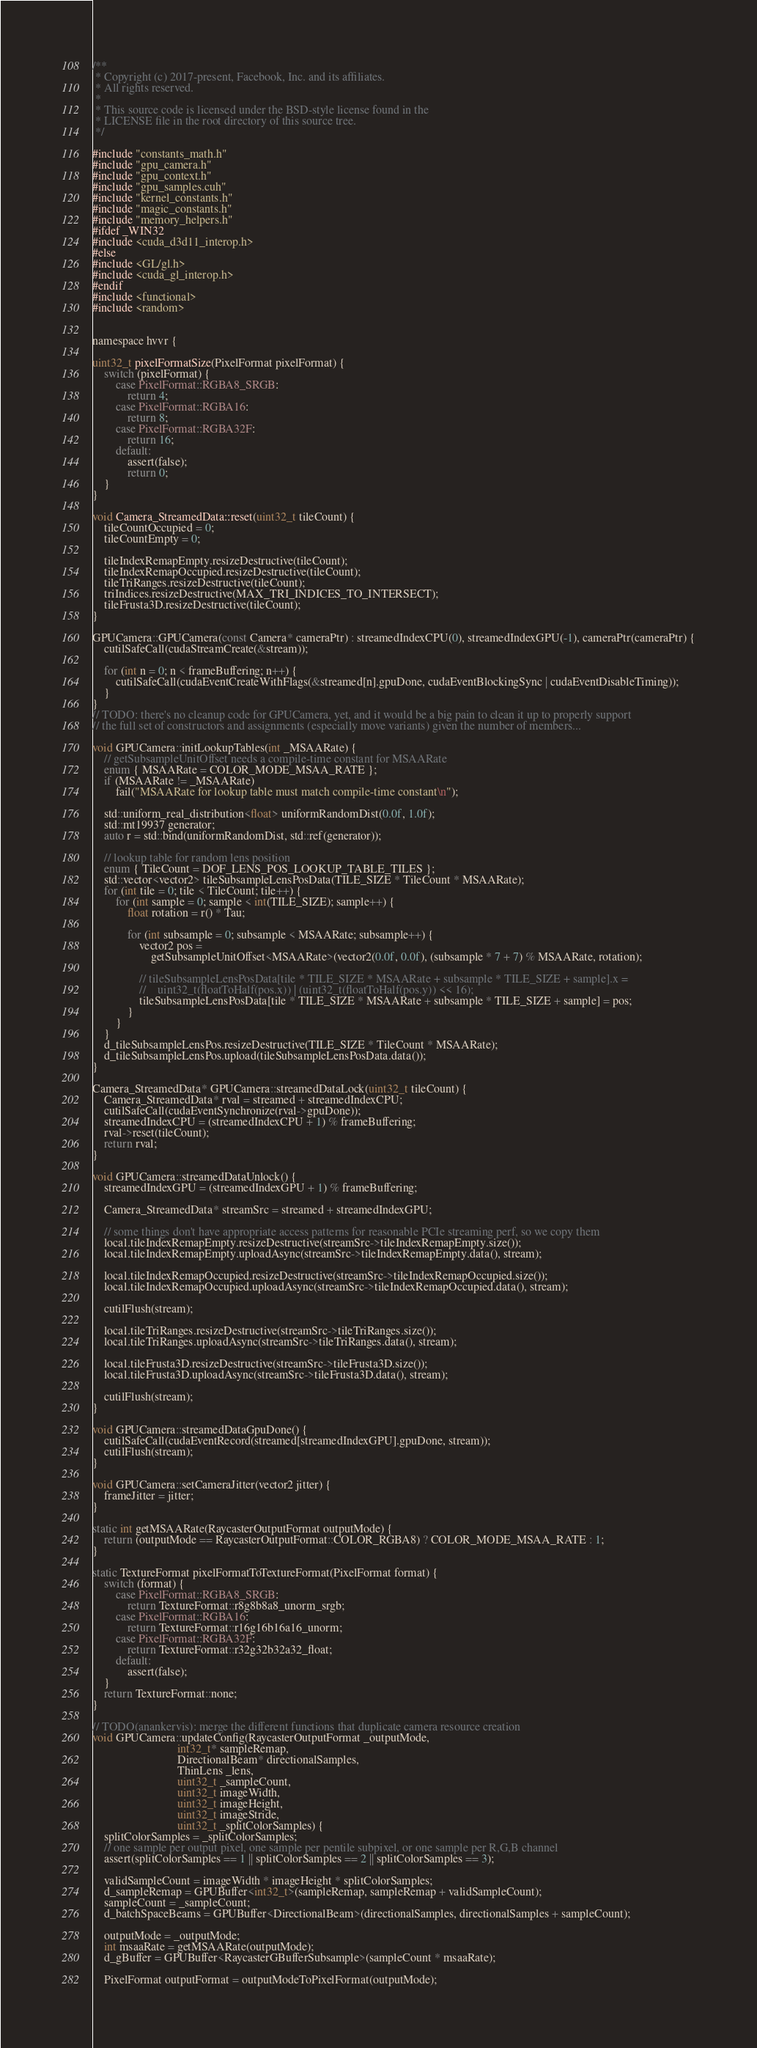<code> <loc_0><loc_0><loc_500><loc_500><_Cuda_>/**
 * Copyright (c) 2017-present, Facebook, Inc. and its affiliates.
 * All rights reserved.
 *
 * This source code is licensed under the BSD-style license found in the
 * LICENSE file in the root directory of this source tree.
 */

#include "constants_math.h"
#include "gpu_camera.h"
#include "gpu_context.h"
#include "gpu_samples.cuh"
#include "kernel_constants.h"
#include "magic_constants.h"
#include "memory_helpers.h"
#ifdef _WIN32
#include <cuda_d3d11_interop.h>
#else
#include <GL/gl.h>
#include <cuda_gl_interop.h>
#endif
#include <functional>
#include <random>


namespace hvvr {

uint32_t pixelFormatSize(PixelFormat pixelFormat) {
    switch (pixelFormat) {
        case PixelFormat::RGBA8_SRGB:
            return 4;
        case PixelFormat::RGBA16:
            return 8;
        case PixelFormat::RGBA32F:
            return 16;
        default:
            assert(false);
            return 0;
    }
}

void Camera_StreamedData::reset(uint32_t tileCount) {
    tileCountOccupied = 0;
    tileCountEmpty = 0;

    tileIndexRemapEmpty.resizeDestructive(tileCount);
    tileIndexRemapOccupied.resizeDestructive(tileCount);
    tileTriRanges.resizeDestructive(tileCount);
    triIndices.resizeDestructive(MAX_TRI_INDICES_TO_INTERSECT);
    tileFrusta3D.resizeDestructive(tileCount);
}

GPUCamera::GPUCamera(const Camera* cameraPtr) : streamedIndexCPU(0), streamedIndexGPU(-1), cameraPtr(cameraPtr) {
    cutilSafeCall(cudaStreamCreate(&stream));

    for (int n = 0; n < frameBuffering; n++) {
        cutilSafeCall(cudaEventCreateWithFlags(&streamed[n].gpuDone, cudaEventBlockingSync | cudaEventDisableTiming));
    }
}
// TODO: there's no cleanup code for GPUCamera, yet, and it would be a big pain to clean it up to properly support
// the full set of constructors and assignments (especially move variants) given the number of members...

void GPUCamera::initLookupTables(int _MSAARate) {
    // getSubsampleUnitOffset needs a compile-time constant for MSAARate
    enum { MSAARate = COLOR_MODE_MSAA_RATE };
    if (MSAARate != _MSAARate)
        fail("MSAARate for lookup table must match compile-time constant\n");

    std::uniform_real_distribution<float> uniformRandomDist(0.0f, 1.0f);
    std::mt19937 generator;
    auto r = std::bind(uniformRandomDist, std::ref(generator));

    // lookup table for random lens position
    enum { TileCount = DOF_LENS_POS_LOOKUP_TABLE_TILES };
    std::vector<vector2> tileSubsampleLensPosData(TILE_SIZE * TileCount * MSAARate);
    for (int tile = 0; tile < TileCount; tile++) {
        for (int sample = 0; sample < int(TILE_SIZE); sample++) {
            float rotation = r() * Tau;

            for (int subsample = 0; subsample < MSAARate; subsample++) {
                vector2 pos =
                    getSubsampleUnitOffset<MSAARate>(vector2(0.0f, 0.0f), (subsample * 7 + 7) % MSAARate, rotation);

                // tileSubsampleLensPosData[tile * TILE_SIZE * MSAARate + subsample * TILE_SIZE + sample].x =
                //    uint32_t(floatToHalf(pos.x)) | (uint32_t(floatToHalf(pos.y)) << 16);
                tileSubsampleLensPosData[tile * TILE_SIZE * MSAARate + subsample * TILE_SIZE + sample] = pos;
            }
        }
    }
    d_tileSubsampleLensPos.resizeDestructive(TILE_SIZE * TileCount * MSAARate);
    d_tileSubsampleLensPos.upload(tileSubsampleLensPosData.data());
}

Camera_StreamedData* GPUCamera::streamedDataLock(uint32_t tileCount) {
    Camera_StreamedData* rval = streamed + streamedIndexCPU;
    cutilSafeCall(cudaEventSynchronize(rval->gpuDone));
    streamedIndexCPU = (streamedIndexCPU + 1) % frameBuffering;
    rval->reset(tileCount);
    return rval;
}

void GPUCamera::streamedDataUnlock() {
    streamedIndexGPU = (streamedIndexGPU + 1) % frameBuffering;

    Camera_StreamedData* streamSrc = streamed + streamedIndexGPU;

    // some things don't have appropriate access patterns for reasonable PCIe streaming perf, so we copy them
    local.tileIndexRemapEmpty.resizeDestructive(streamSrc->tileIndexRemapEmpty.size());
    local.tileIndexRemapEmpty.uploadAsync(streamSrc->tileIndexRemapEmpty.data(), stream);

    local.tileIndexRemapOccupied.resizeDestructive(streamSrc->tileIndexRemapOccupied.size());
    local.tileIndexRemapOccupied.uploadAsync(streamSrc->tileIndexRemapOccupied.data(), stream);

    cutilFlush(stream);

    local.tileTriRanges.resizeDestructive(streamSrc->tileTriRanges.size());
    local.tileTriRanges.uploadAsync(streamSrc->tileTriRanges.data(), stream);

    local.tileFrusta3D.resizeDestructive(streamSrc->tileFrusta3D.size());
    local.tileFrusta3D.uploadAsync(streamSrc->tileFrusta3D.data(), stream);

    cutilFlush(stream);
}

void GPUCamera::streamedDataGpuDone() {
    cutilSafeCall(cudaEventRecord(streamed[streamedIndexGPU].gpuDone, stream));
    cutilFlush(stream);
}

void GPUCamera::setCameraJitter(vector2 jitter) {
    frameJitter = jitter;
}

static int getMSAARate(RaycasterOutputFormat outputMode) {
    return (outputMode == RaycasterOutputFormat::COLOR_RGBA8) ? COLOR_MODE_MSAA_RATE : 1;
}

static TextureFormat pixelFormatToTextureFormat(PixelFormat format) {
    switch (format) {
        case PixelFormat::RGBA8_SRGB:
            return TextureFormat::r8g8b8a8_unorm_srgb;
        case PixelFormat::RGBA16:
            return TextureFormat::r16g16b16a16_unorm;
        case PixelFormat::RGBA32F:
            return TextureFormat::r32g32b32a32_float;
        default:
            assert(false);
    }
    return TextureFormat::none;
}

// TODO(anankervis): merge the different functions that duplicate camera resource creation
void GPUCamera::updateConfig(RaycasterOutputFormat _outputMode,
                             int32_t* sampleRemap,
                             DirectionalBeam* directionalSamples,
                             ThinLens _lens,
                             uint32_t _sampleCount,
                             uint32_t imageWidth,
                             uint32_t imageHeight,
                             uint32_t imageStride,
                             uint32_t _splitColorSamples) {
    splitColorSamples = _splitColorSamples;
    // one sample per output pixel, one sample per pentile subpixel, or one sample per R,G,B channel
    assert(splitColorSamples == 1 || splitColorSamples == 2 || splitColorSamples == 3);

    validSampleCount = imageWidth * imageHeight * splitColorSamples;
    d_sampleRemap = GPUBuffer<int32_t>(sampleRemap, sampleRemap + validSampleCount);
    sampleCount = _sampleCount;
    d_batchSpaceBeams = GPUBuffer<DirectionalBeam>(directionalSamples, directionalSamples + sampleCount);

    outputMode = _outputMode;
    int msaaRate = getMSAARate(outputMode);
    d_gBuffer = GPUBuffer<RaycasterGBufferSubsample>(sampleCount * msaaRate);

    PixelFormat outputFormat = outputModeToPixelFormat(outputMode);</code> 